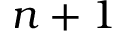<formula> <loc_0><loc_0><loc_500><loc_500>n + 1</formula> 